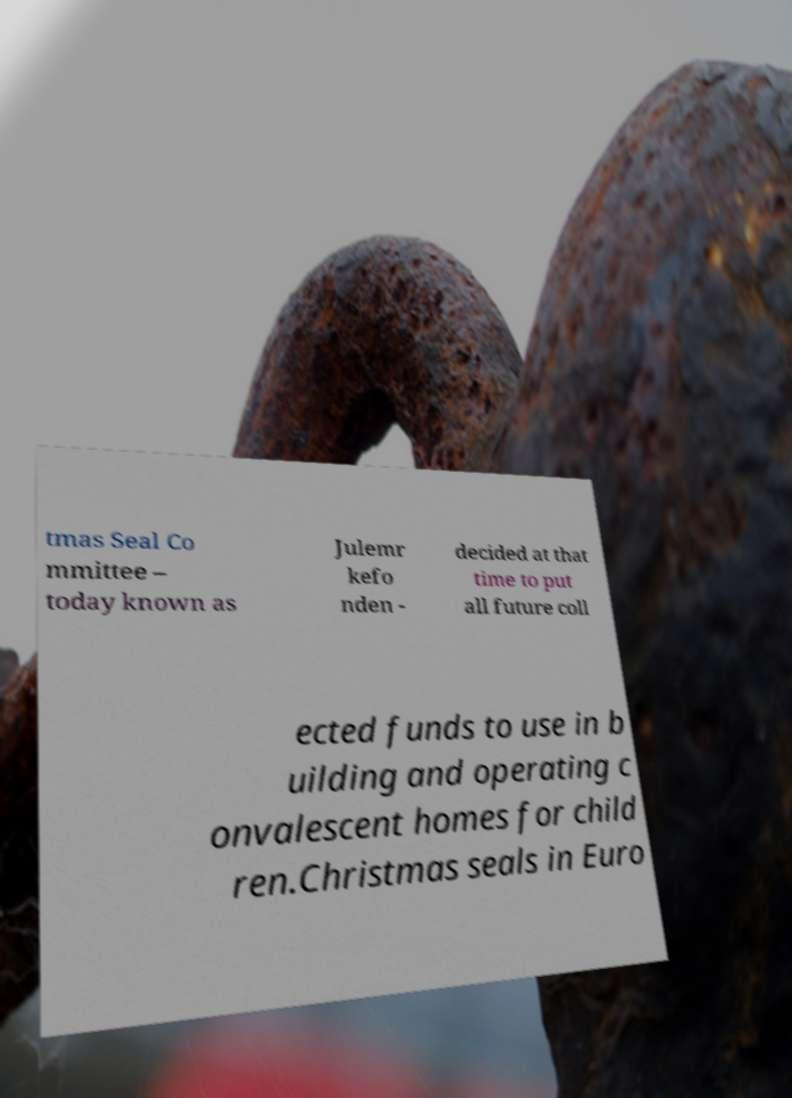Can you accurately transcribe the text from the provided image for me? tmas Seal Co mmittee – today known as Julemr kefo nden - decided at that time to put all future coll ected funds to use in b uilding and operating c onvalescent homes for child ren.Christmas seals in Euro 